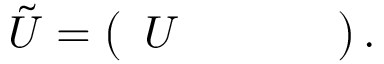Convert formula to latex. <formula><loc_0><loc_0><loc_500><loc_500>\tilde { U } = \left ( \begin{array} { l l l l } { U } \end{array} \right ) .</formula> 